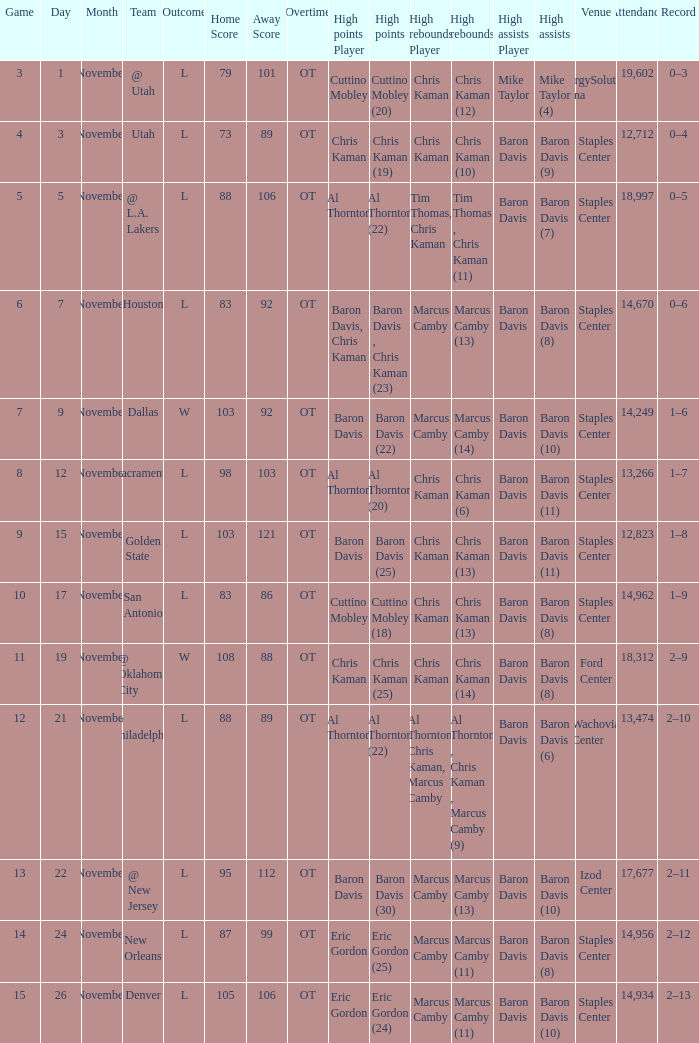Name the total number of score for staples center 13,266 1.0. 